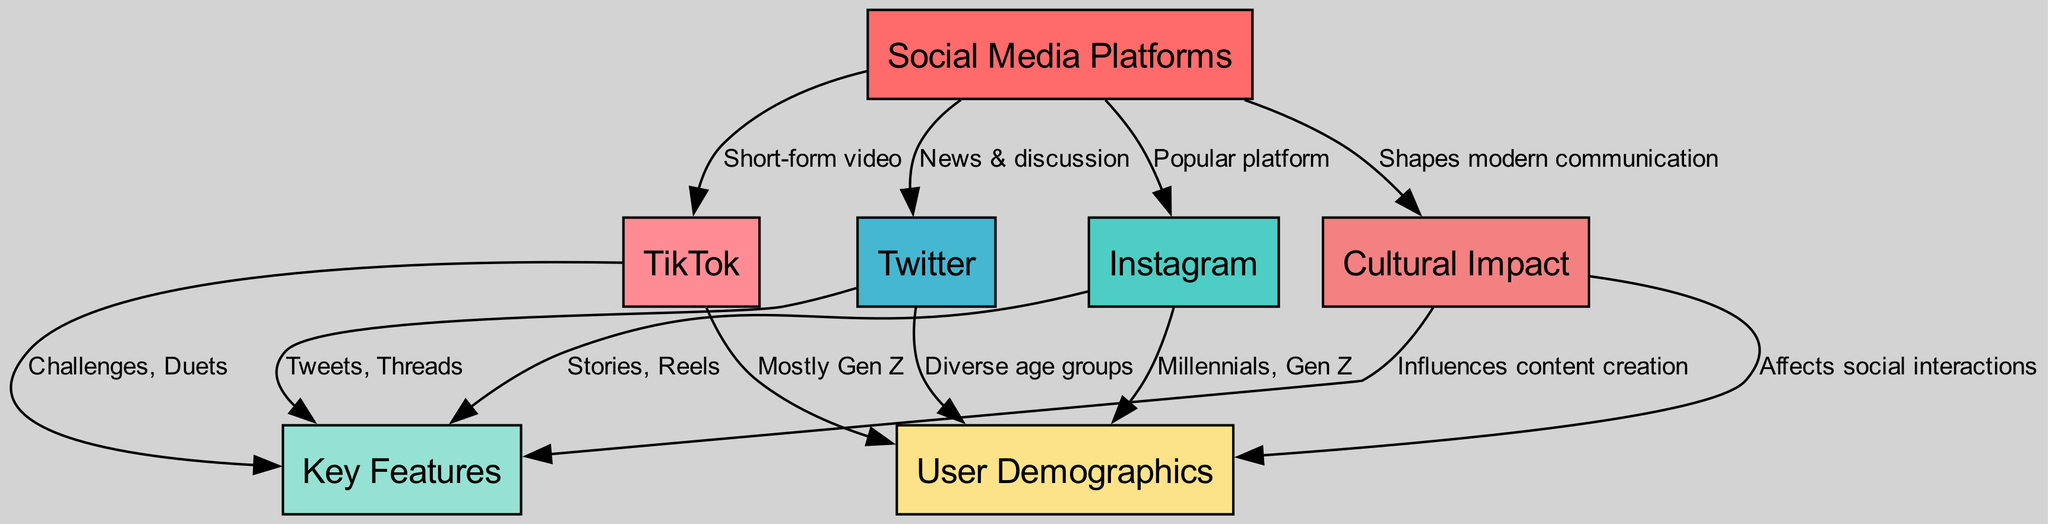What are the key features of Instagram? The diagram specifies that Instagram has the features "Stories, Reels." These are listed as characteristics unique to the platform under the features node, connected through the edge labeled with "features."
Answer: Stories, Reels Which social media platform is known for short-form video? The edge from the social media node to TikTok indicates that TikTok is specifically recognized for this type of content, as labeled with "Short-form video."
Answer: TikTok How many platforms are listed in the diagram? By counting the number of nodes related to social media platforms in the diagram, we find three distinct platforms listed: Instagram, Twitter, and TikTok.
Answer: 3 What is one demographic characteristic associated with Twitter? According to the diagram, Twitter is connected to the demographics node stating "Diverse age groups," indicating the platform attracts users from various demographics.
Answer: Diverse age groups What cultural impact do social media platforms have according to the diagram? The diagram connects the impact node to the statement that platforms "Shapes modern communication," indicating the broad influence social media has on how people communicate today.
Answer: Shapes modern communication What influences content creation in the context of the diagram? The relationship between the impact node and the features node indicates that social media impact influences how content is created, as it states "Influences content creation."
Answer: Influences content creation Which demographic is mostly associated with TikTok? The diagram shows a connection from TikTok to the demographics node, specifically mentioning "Mostly Gen Z," which reflects the primary user base of the platform.
Answer: Mostly Gen Z What do Instagram and Twitter have in common regarding user demographics? Analyzing the connections to the demographics node, Instagram targets "Millennials, Gen Z," while Twitter has "Diverse age groups." They both cater to a broad range of users, though Instagram is more focused on younger users.
Answer: Broad user base Which feature is unique to TikTok compared to Instagram and Twitter? The features connected to TikTok specifically mention "Challenges, Duets," which are not mentioned for Instagram or Twitter, highlighting a unique aspect of TikTok's feature set.
Answer: Challenges, Duets 